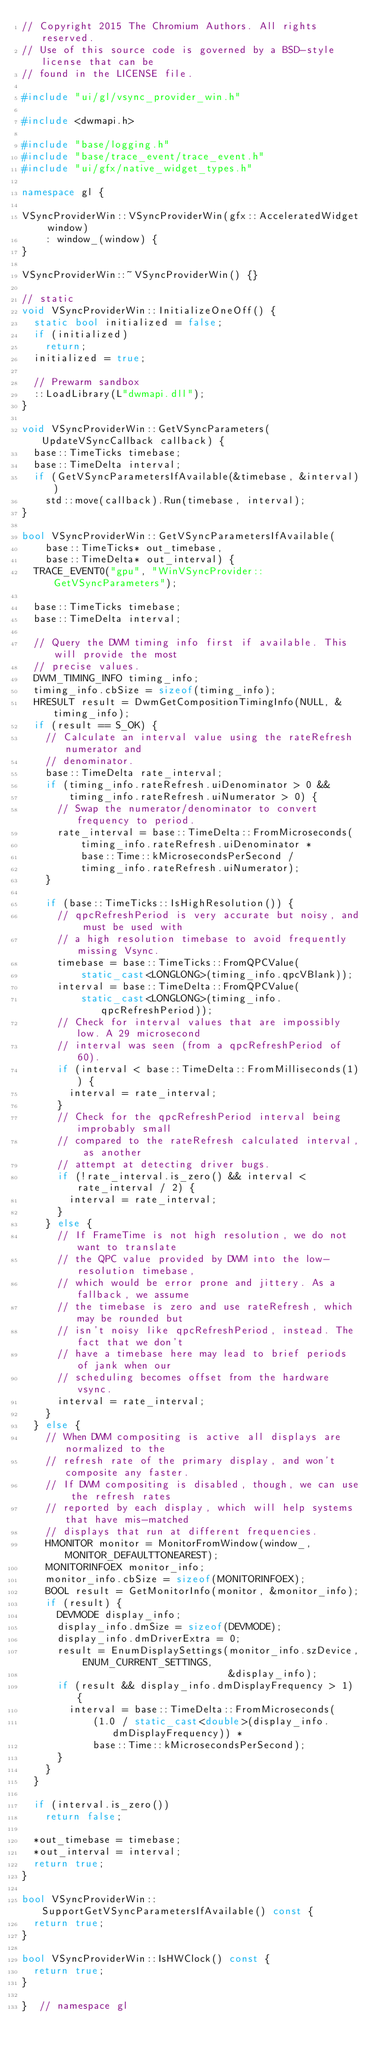<code> <loc_0><loc_0><loc_500><loc_500><_C++_>// Copyright 2015 The Chromium Authors. All rights reserved.
// Use of this source code is governed by a BSD-style license that can be
// found in the LICENSE file.

#include "ui/gl/vsync_provider_win.h"

#include <dwmapi.h>

#include "base/logging.h"
#include "base/trace_event/trace_event.h"
#include "ui/gfx/native_widget_types.h"

namespace gl {

VSyncProviderWin::VSyncProviderWin(gfx::AcceleratedWidget window)
    : window_(window) {
}

VSyncProviderWin::~VSyncProviderWin() {}

// static
void VSyncProviderWin::InitializeOneOff() {
  static bool initialized = false;
  if (initialized)
    return;
  initialized = true;

  // Prewarm sandbox
  ::LoadLibrary(L"dwmapi.dll");
}

void VSyncProviderWin::GetVSyncParameters(UpdateVSyncCallback callback) {
  base::TimeTicks timebase;
  base::TimeDelta interval;
  if (GetVSyncParametersIfAvailable(&timebase, &interval))
    std::move(callback).Run(timebase, interval);
}

bool VSyncProviderWin::GetVSyncParametersIfAvailable(
    base::TimeTicks* out_timebase,
    base::TimeDelta* out_interval) {
  TRACE_EVENT0("gpu", "WinVSyncProvider::GetVSyncParameters");

  base::TimeTicks timebase;
  base::TimeDelta interval;

  // Query the DWM timing info first if available. This will provide the most
  // precise values.
  DWM_TIMING_INFO timing_info;
  timing_info.cbSize = sizeof(timing_info);
  HRESULT result = DwmGetCompositionTimingInfo(NULL, &timing_info);
  if (result == S_OK) {
    // Calculate an interval value using the rateRefresh numerator and
    // denominator.
    base::TimeDelta rate_interval;
    if (timing_info.rateRefresh.uiDenominator > 0 &&
        timing_info.rateRefresh.uiNumerator > 0) {
      // Swap the numerator/denominator to convert frequency to period.
      rate_interval = base::TimeDelta::FromMicroseconds(
          timing_info.rateRefresh.uiDenominator *
          base::Time::kMicrosecondsPerSecond /
          timing_info.rateRefresh.uiNumerator);
    }

    if (base::TimeTicks::IsHighResolution()) {
      // qpcRefreshPeriod is very accurate but noisy, and must be used with
      // a high resolution timebase to avoid frequently missing Vsync.
      timebase = base::TimeTicks::FromQPCValue(
          static_cast<LONGLONG>(timing_info.qpcVBlank));
      interval = base::TimeDelta::FromQPCValue(
          static_cast<LONGLONG>(timing_info.qpcRefreshPeriod));
      // Check for interval values that are impossibly low. A 29 microsecond
      // interval was seen (from a qpcRefreshPeriod of 60).
      if (interval < base::TimeDelta::FromMilliseconds(1)) {
        interval = rate_interval;
      }
      // Check for the qpcRefreshPeriod interval being improbably small
      // compared to the rateRefresh calculated interval, as another
      // attempt at detecting driver bugs.
      if (!rate_interval.is_zero() && interval < rate_interval / 2) {
        interval = rate_interval;
      }
    } else {
      // If FrameTime is not high resolution, we do not want to translate
      // the QPC value provided by DWM into the low-resolution timebase,
      // which would be error prone and jittery. As a fallback, we assume
      // the timebase is zero and use rateRefresh, which may be rounded but
      // isn't noisy like qpcRefreshPeriod, instead. The fact that we don't
      // have a timebase here may lead to brief periods of jank when our
      // scheduling becomes offset from the hardware vsync.
      interval = rate_interval;
    }
  } else {
    // When DWM compositing is active all displays are normalized to the
    // refresh rate of the primary display, and won't composite any faster.
    // If DWM compositing is disabled, though, we can use the refresh rates
    // reported by each display, which will help systems that have mis-matched
    // displays that run at different frequencies.
    HMONITOR monitor = MonitorFromWindow(window_, MONITOR_DEFAULTTONEAREST);
    MONITORINFOEX monitor_info;
    monitor_info.cbSize = sizeof(MONITORINFOEX);
    BOOL result = GetMonitorInfo(monitor, &monitor_info);
    if (result) {
      DEVMODE display_info;
      display_info.dmSize = sizeof(DEVMODE);
      display_info.dmDriverExtra = 0;
      result = EnumDisplaySettings(monitor_info.szDevice, ENUM_CURRENT_SETTINGS,
                                   &display_info);
      if (result && display_info.dmDisplayFrequency > 1) {
        interval = base::TimeDelta::FromMicroseconds(
            (1.0 / static_cast<double>(display_info.dmDisplayFrequency)) *
            base::Time::kMicrosecondsPerSecond);
      }
    }
  }

  if (interval.is_zero())
    return false;

  *out_timebase = timebase;
  *out_interval = interval;
  return true;
}

bool VSyncProviderWin::SupportGetVSyncParametersIfAvailable() const {
  return true;
}

bool VSyncProviderWin::IsHWClock() const {
  return true;
}

}  // namespace gl
</code> 